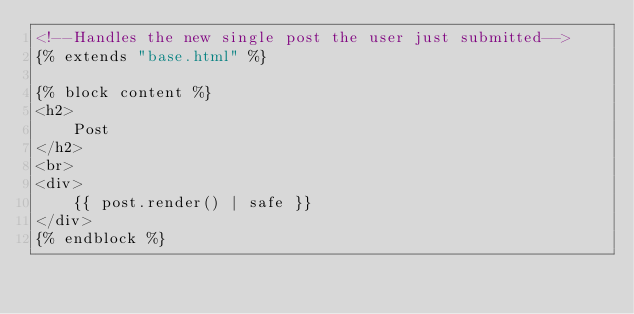<code> <loc_0><loc_0><loc_500><loc_500><_HTML_><!--Handles the new single post the user just submitted-->
{% extends "base.html" %}

{% block content %}
<h2>
    Post
</h2>
<br>
<div>
    {{ post.render() | safe }}
</div>
{% endblock %}</code> 